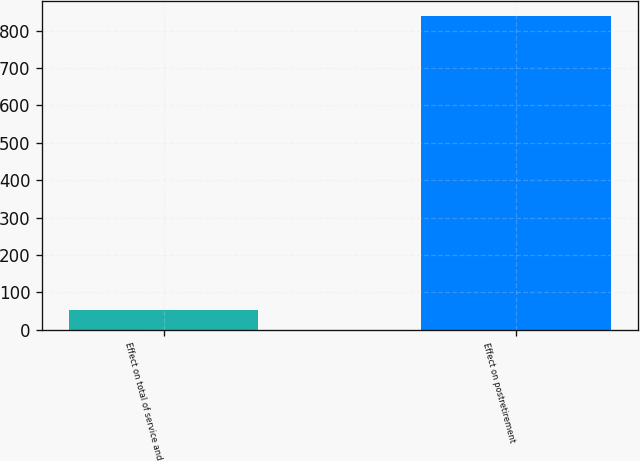Convert chart. <chart><loc_0><loc_0><loc_500><loc_500><bar_chart><fcel>Effect on total of service and<fcel>Effect on postretirement<nl><fcel>52<fcel>838<nl></chart> 